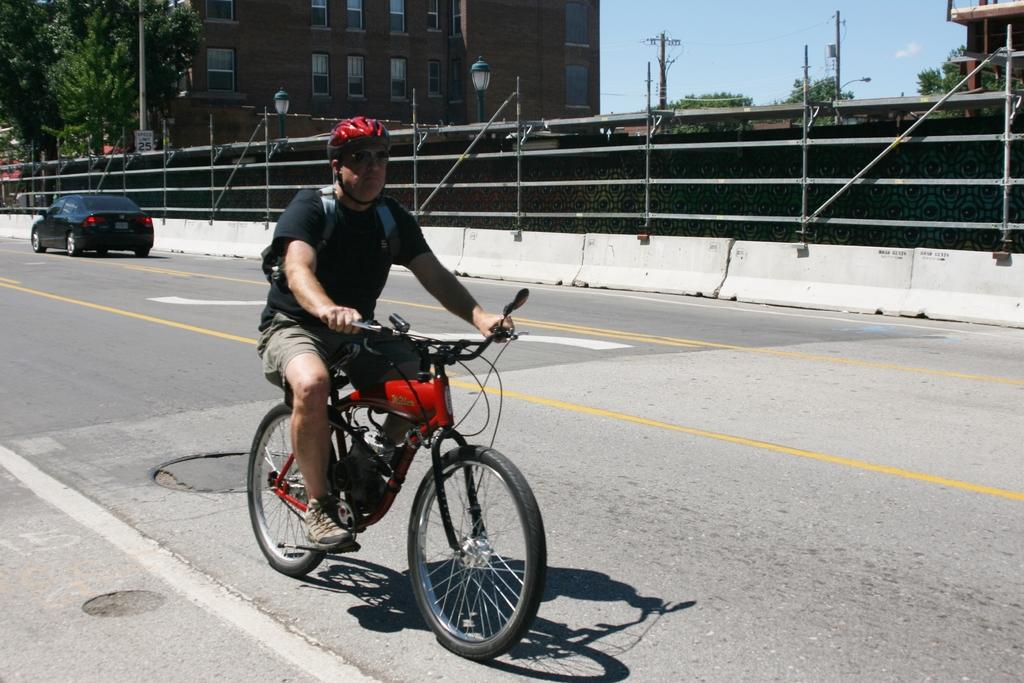What is the man in the image doing? The man is on a bicycle in the image. What type of path is visible in the image? There is a road in the image. What other vehicle can be seen in the image? There is a car in the image. What structure is present in the image? There is a building in the image. What type of vegetation is visible in the image? There are trees in the image. What object is standing upright in the image? There is a pole in the image. What scent is emanating from the dime in the image? There is no dime present in the image, so it is not possible to determine any scent. 